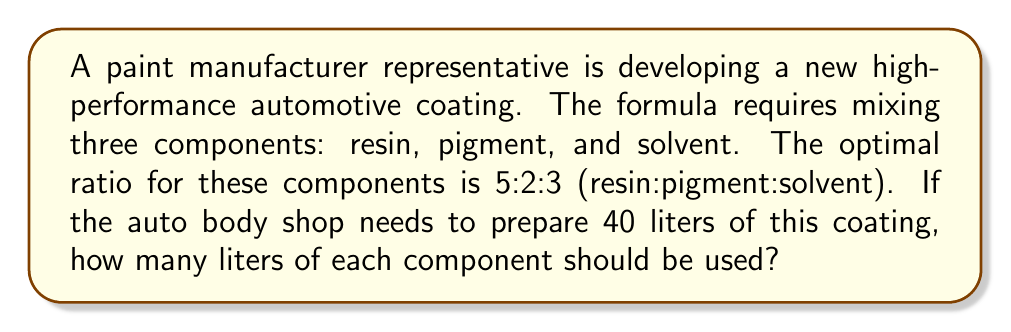Teach me how to tackle this problem. Let's approach this step-by-step:

1) First, we need to understand what the ratio 5:2:3 means. It indicates that for every 5 parts of resin, we need 2 parts of pigment and 3 parts of solvent.

2) To find the total parts in the ratio, we add these numbers:
   $5 + 2 + 3 = 10$ total parts

3) Now, we need to determine what fraction of the total mixture each component represents:

   Resin: $\frac{5}{10} = \frac{1}{2}$
   Pigment: $\frac{2}{10} = \frac{1}{5}$
   Solvent: $\frac{3}{10}$

4) Given that we need to prepare 40 liters in total, we can calculate the amount of each component:

   Resin: $40 \times \frac{1}{2} = 20$ liters
   Pigment: $40 \times \frac{1}{5} = 8$ liters
   Solvent: $40 \times \frac{3}{10} = 12$ liters

5) Let's verify our calculations:
   $20 + 8 + 12 = 40$ liters, which matches our total required amount.

Therefore, to prepare 40 liters of the coating with the optimal ratio, we need 20 liters of resin, 8 liters of pigment, and 12 liters of solvent.
Answer: Resin: 20 liters
Pigment: 8 liters
Solvent: 12 liters 